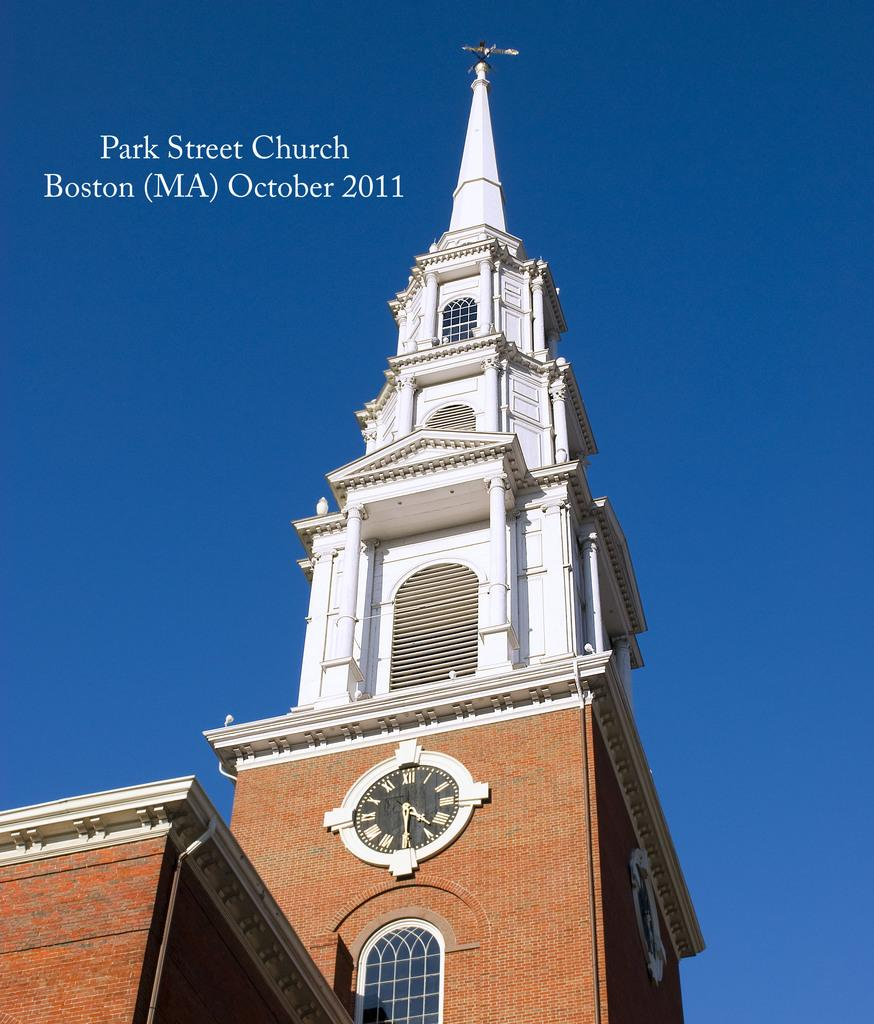<image>
Write a terse but informative summary of the picture. A photo of Park Street Church Boston, MA. taken in Oct. 2011. 